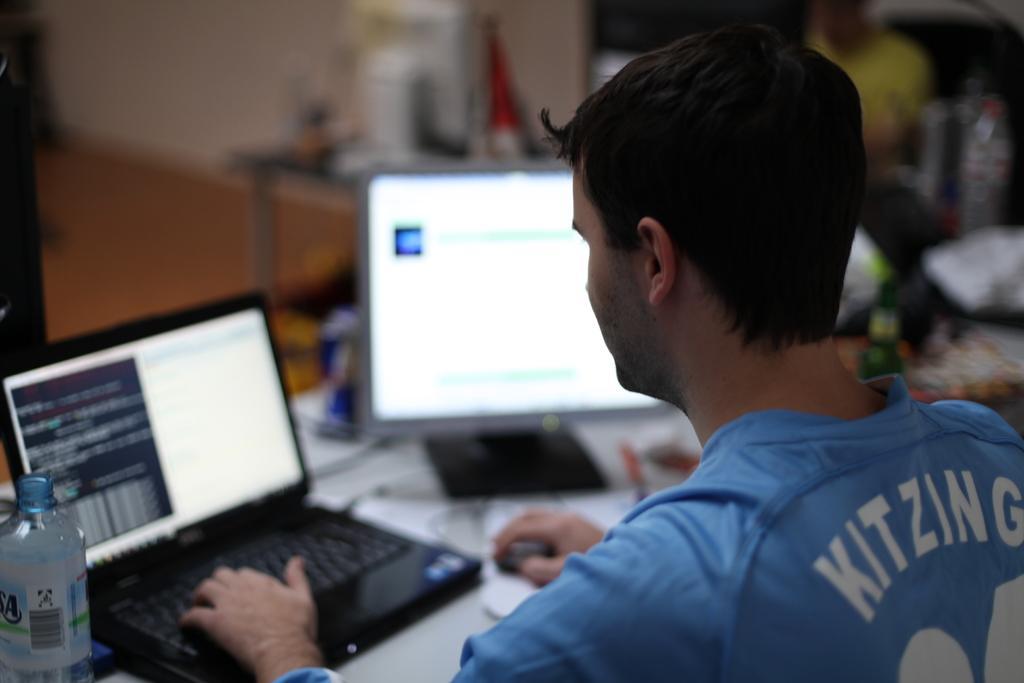Describe this image in one or two sentences. This picture seems to be clicked inside the room. On the right we can see the two persons sitting on the chairs and seems to be working on a laptop and we can see a monitor and many other objects are placed on the top of the tables. In the background we can see the wall and some other objects. 